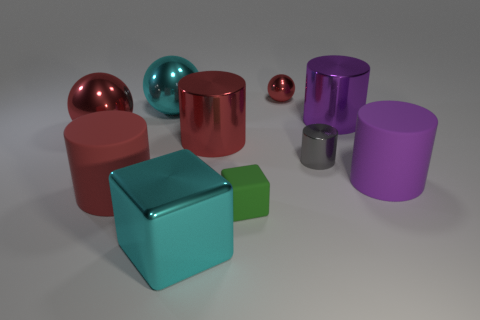The metallic ball in front of the large purple metal object on the left side of the purple matte thing is what color?
Keep it short and to the point. Red. How many green things are tiny shiny objects or tiny things?
Your answer should be compact. 1. What color is the large cylinder that is on the right side of the tiny gray cylinder and behind the gray object?
Provide a short and direct response. Purple. What number of large things are either red matte things or purple metallic cylinders?
Ensure brevity in your answer.  2. There is a gray object that is the same shape as the red matte object; what is its size?
Ensure brevity in your answer.  Small. What shape is the gray object?
Ensure brevity in your answer.  Cylinder. Does the tiny red ball have the same material as the red cylinder left of the large block?
Keep it short and to the point. No. What number of metallic things are big red cubes or gray cylinders?
Your answer should be compact. 1. There is a red thing that is in front of the small gray cylinder; how big is it?
Give a very brief answer. Large. The purple cylinder that is the same material as the tiny gray object is what size?
Offer a very short reply. Large. 